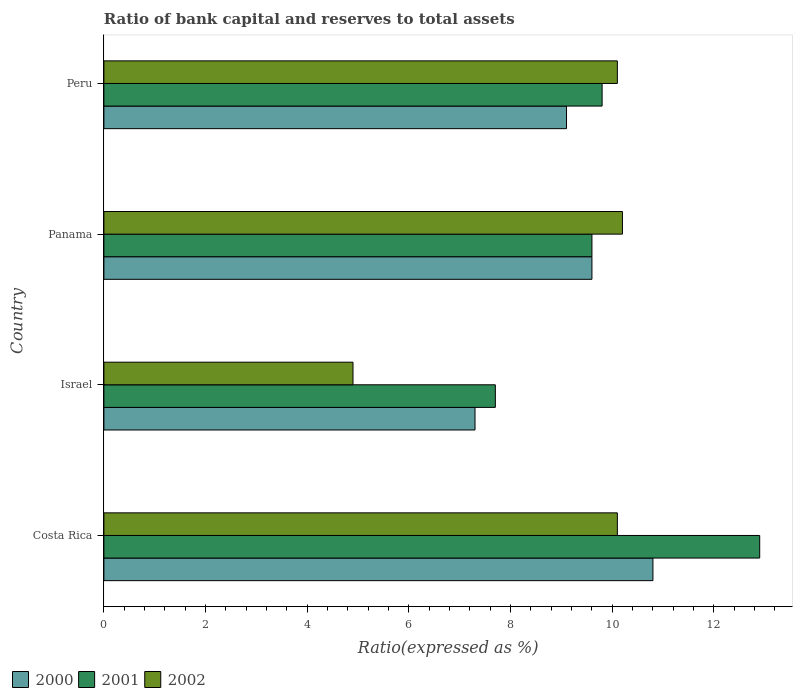How many different coloured bars are there?
Your answer should be very brief. 3. Are the number of bars per tick equal to the number of legend labels?
Offer a terse response. Yes. Are the number of bars on each tick of the Y-axis equal?
Make the answer very short. Yes. How many bars are there on the 1st tick from the bottom?
Make the answer very short. 3. Across all countries, what is the minimum ratio of bank capital and reserves to total assets in 2002?
Ensure brevity in your answer.  4.9. What is the total ratio of bank capital and reserves to total assets in 2000 in the graph?
Give a very brief answer. 36.8. What is the difference between the ratio of bank capital and reserves to total assets in 2002 in Costa Rica and that in Israel?
Offer a very short reply. 5.2. What is the average ratio of bank capital and reserves to total assets in 2002 per country?
Ensure brevity in your answer.  8.82. In how many countries, is the ratio of bank capital and reserves to total assets in 2002 greater than 1.2000000000000002 %?
Provide a short and direct response. 4. What is the ratio of the ratio of bank capital and reserves to total assets in 2001 in Israel to that in Peru?
Provide a short and direct response. 0.79. What is the difference between the highest and the second highest ratio of bank capital and reserves to total assets in 2000?
Give a very brief answer. 1.2. What is the difference between the highest and the lowest ratio of bank capital and reserves to total assets in 2001?
Provide a short and direct response. 5.2. In how many countries, is the ratio of bank capital and reserves to total assets in 2000 greater than the average ratio of bank capital and reserves to total assets in 2000 taken over all countries?
Make the answer very short. 2. Is the sum of the ratio of bank capital and reserves to total assets in 2001 in Costa Rica and Peru greater than the maximum ratio of bank capital and reserves to total assets in 2002 across all countries?
Make the answer very short. Yes. Is it the case that in every country, the sum of the ratio of bank capital and reserves to total assets in 2000 and ratio of bank capital and reserves to total assets in 2002 is greater than the ratio of bank capital and reserves to total assets in 2001?
Make the answer very short. Yes. Does the graph contain any zero values?
Provide a succinct answer. No. Does the graph contain grids?
Ensure brevity in your answer.  No. Where does the legend appear in the graph?
Provide a succinct answer. Bottom left. How are the legend labels stacked?
Give a very brief answer. Horizontal. What is the title of the graph?
Provide a succinct answer. Ratio of bank capital and reserves to total assets. What is the label or title of the X-axis?
Keep it short and to the point. Ratio(expressed as %). What is the label or title of the Y-axis?
Offer a terse response. Country. What is the Ratio(expressed as %) of 2000 in Costa Rica?
Your answer should be very brief. 10.8. What is the Ratio(expressed as %) in 2001 in Costa Rica?
Your answer should be compact. 12.9. What is the Ratio(expressed as %) in 2002 in Costa Rica?
Keep it short and to the point. 10.1. What is the Ratio(expressed as %) of 2001 in Israel?
Provide a short and direct response. 7.7. What is the Ratio(expressed as %) of 2002 in Israel?
Offer a very short reply. 4.9. What is the Ratio(expressed as %) of 2001 in Panama?
Your answer should be very brief. 9.6. What is the Ratio(expressed as %) in 2000 in Peru?
Ensure brevity in your answer.  9.1. What is the Ratio(expressed as %) in 2002 in Peru?
Your answer should be compact. 10.1. Across all countries, what is the maximum Ratio(expressed as %) of 2001?
Provide a short and direct response. 12.9. Across all countries, what is the maximum Ratio(expressed as %) in 2002?
Provide a short and direct response. 10.2. Across all countries, what is the minimum Ratio(expressed as %) of 2000?
Offer a terse response. 7.3. What is the total Ratio(expressed as %) of 2000 in the graph?
Offer a terse response. 36.8. What is the total Ratio(expressed as %) of 2001 in the graph?
Offer a terse response. 40. What is the total Ratio(expressed as %) in 2002 in the graph?
Give a very brief answer. 35.3. What is the difference between the Ratio(expressed as %) in 2000 in Costa Rica and that in Israel?
Ensure brevity in your answer.  3.5. What is the difference between the Ratio(expressed as %) of 2002 in Costa Rica and that in Panama?
Your answer should be very brief. -0.1. What is the difference between the Ratio(expressed as %) of 2002 in Costa Rica and that in Peru?
Ensure brevity in your answer.  0. What is the difference between the Ratio(expressed as %) of 2000 in Israel and that in Panama?
Make the answer very short. -2.3. What is the difference between the Ratio(expressed as %) of 2002 in Israel and that in Panama?
Give a very brief answer. -5.3. What is the difference between the Ratio(expressed as %) of 2000 in Israel and that in Peru?
Offer a very short reply. -1.8. What is the difference between the Ratio(expressed as %) in 2002 in Israel and that in Peru?
Your response must be concise. -5.2. What is the difference between the Ratio(expressed as %) of 2000 in Panama and that in Peru?
Provide a succinct answer. 0.5. What is the difference between the Ratio(expressed as %) in 2000 in Costa Rica and the Ratio(expressed as %) in 2001 in Israel?
Give a very brief answer. 3.1. What is the difference between the Ratio(expressed as %) in 2000 in Costa Rica and the Ratio(expressed as %) in 2002 in Israel?
Offer a terse response. 5.9. What is the difference between the Ratio(expressed as %) of 2001 in Costa Rica and the Ratio(expressed as %) of 2002 in Panama?
Offer a very short reply. 2.7. What is the difference between the Ratio(expressed as %) of 2000 in Costa Rica and the Ratio(expressed as %) of 2001 in Peru?
Give a very brief answer. 1. What is the difference between the Ratio(expressed as %) in 2000 in Costa Rica and the Ratio(expressed as %) in 2002 in Peru?
Provide a succinct answer. 0.7. What is the difference between the Ratio(expressed as %) of 2000 in Israel and the Ratio(expressed as %) of 2002 in Panama?
Ensure brevity in your answer.  -2.9. What is the difference between the Ratio(expressed as %) of 2000 in Israel and the Ratio(expressed as %) of 2001 in Peru?
Keep it short and to the point. -2.5. What is the difference between the Ratio(expressed as %) of 2000 in Israel and the Ratio(expressed as %) of 2002 in Peru?
Provide a succinct answer. -2.8. What is the difference between the Ratio(expressed as %) in 2001 in Israel and the Ratio(expressed as %) in 2002 in Peru?
Make the answer very short. -2.4. What is the difference between the Ratio(expressed as %) of 2000 in Panama and the Ratio(expressed as %) of 2001 in Peru?
Give a very brief answer. -0.2. What is the difference between the Ratio(expressed as %) in 2000 in Panama and the Ratio(expressed as %) in 2002 in Peru?
Your answer should be compact. -0.5. What is the average Ratio(expressed as %) of 2000 per country?
Provide a succinct answer. 9.2. What is the average Ratio(expressed as %) in 2001 per country?
Make the answer very short. 10. What is the average Ratio(expressed as %) in 2002 per country?
Your answer should be compact. 8.82. What is the difference between the Ratio(expressed as %) in 2000 and Ratio(expressed as %) in 2001 in Costa Rica?
Give a very brief answer. -2.1. What is the difference between the Ratio(expressed as %) in 2001 and Ratio(expressed as %) in 2002 in Costa Rica?
Give a very brief answer. 2.8. What is the difference between the Ratio(expressed as %) of 2000 and Ratio(expressed as %) of 2002 in Israel?
Provide a short and direct response. 2.4. What is the difference between the Ratio(expressed as %) of 2001 and Ratio(expressed as %) of 2002 in Israel?
Give a very brief answer. 2.8. What is the difference between the Ratio(expressed as %) of 2001 and Ratio(expressed as %) of 2002 in Panama?
Ensure brevity in your answer.  -0.6. What is the difference between the Ratio(expressed as %) in 2000 and Ratio(expressed as %) in 2001 in Peru?
Offer a terse response. -0.7. What is the difference between the Ratio(expressed as %) of 2001 and Ratio(expressed as %) of 2002 in Peru?
Your answer should be very brief. -0.3. What is the ratio of the Ratio(expressed as %) of 2000 in Costa Rica to that in Israel?
Provide a short and direct response. 1.48. What is the ratio of the Ratio(expressed as %) in 2001 in Costa Rica to that in Israel?
Offer a terse response. 1.68. What is the ratio of the Ratio(expressed as %) in 2002 in Costa Rica to that in Israel?
Your response must be concise. 2.06. What is the ratio of the Ratio(expressed as %) in 2001 in Costa Rica to that in Panama?
Provide a succinct answer. 1.34. What is the ratio of the Ratio(expressed as %) of 2002 in Costa Rica to that in Panama?
Provide a short and direct response. 0.99. What is the ratio of the Ratio(expressed as %) of 2000 in Costa Rica to that in Peru?
Your response must be concise. 1.19. What is the ratio of the Ratio(expressed as %) in 2001 in Costa Rica to that in Peru?
Your answer should be compact. 1.32. What is the ratio of the Ratio(expressed as %) of 2002 in Costa Rica to that in Peru?
Keep it short and to the point. 1. What is the ratio of the Ratio(expressed as %) of 2000 in Israel to that in Panama?
Your answer should be compact. 0.76. What is the ratio of the Ratio(expressed as %) in 2001 in Israel to that in Panama?
Ensure brevity in your answer.  0.8. What is the ratio of the Ratio(expressed as %) of 2002 in Israel to that in Panama?
Provide a succinct answer. 0.48. What is the ratio of the Ratio(expressed as %) in 2000 in Israel to that in Peru?
Your answer should be compact. 0.8. What is the ratio of the Ratio(expressed as %) in 2001 in Israel to that in Peru?
Make the answer very short. 0.79. What is the ratio of the Ratio(expressed as %) of 2002 in Israel to that in Peru?
Your answer should be very brief. 0.49. What is the ratio of the Ratio(expressed as %) in 2000 in Panama to that in Peru?
Your response must be concise. 1.05. What is the ratio of the Ratio(expressed as %) of 2001 in Panama to that in Peru?
Ensure brevity in your answer.  0.98. What is the ratio of the Ratio(expressed as %) in 2002 in Panama to that in Peru?
Provide a succinct answer. 1.01. What is the difference between the highest and the second highest Ratio(expressed as %) of 2000?
Give a very brief answer. 1.2. What is the difference between the highest and the second highest Ratio(expressed as %) of 2002?
Provide a short and direct response. 0.1. What is the difference between the highest and the lowest Ratio(expressed as %) in 2001?
Offer a very short reply. 5.2. 